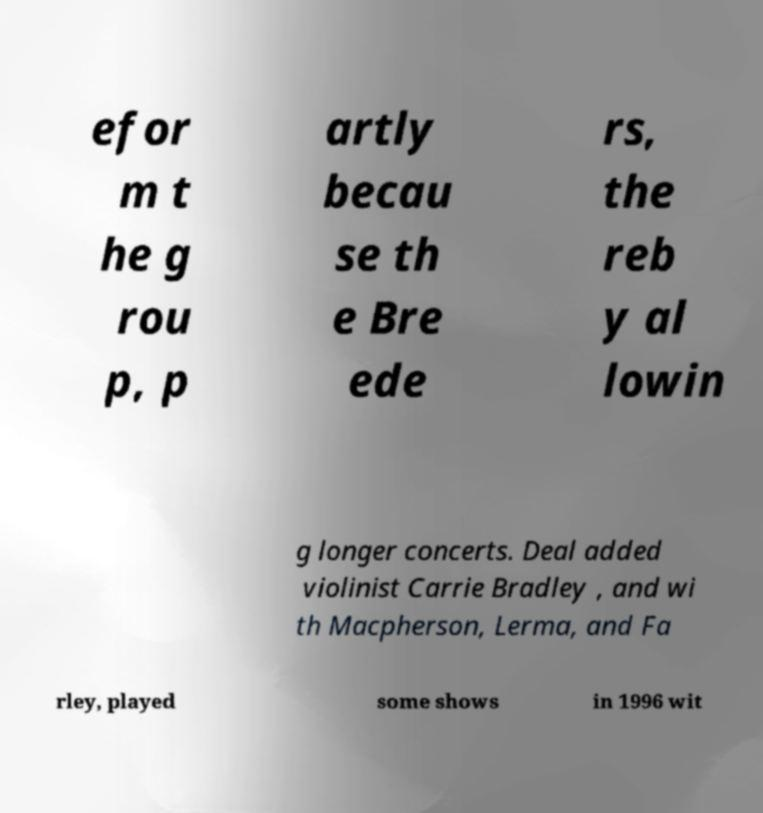Could you assist in decoding the text presented in this image and type it out clearly? efor m t he g rou p, p artly becau se th e Bre ede rs, the reb y al lowin g longer concerts. Deal added violinist Carrie Bradley , and wi th Macpherson, Lerma, and Fa rley, played some shows in 1996 wit 